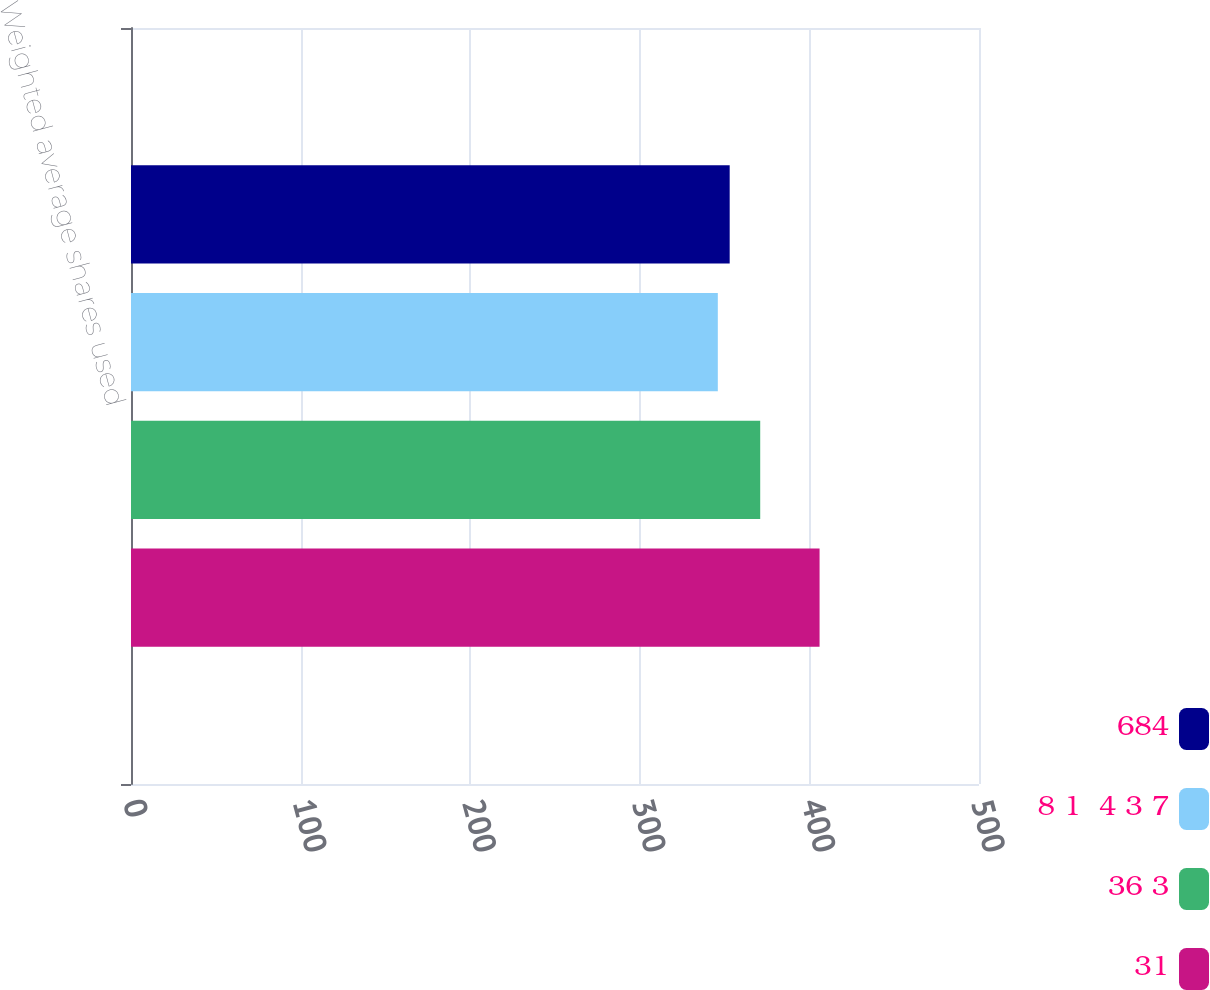Convert chart. <chart><loc_0><loc_0><loc_500><loc_500><stacked_bar_chart><ecel><fcel>Weighted average shares used<nl><fcel>684<fcel>353<nl><fcel>8 1  4 3 7<fcel>346<nl><fcel>36 3<fcel>371<nl><fcel>31<fcel>406<nl></chart> 